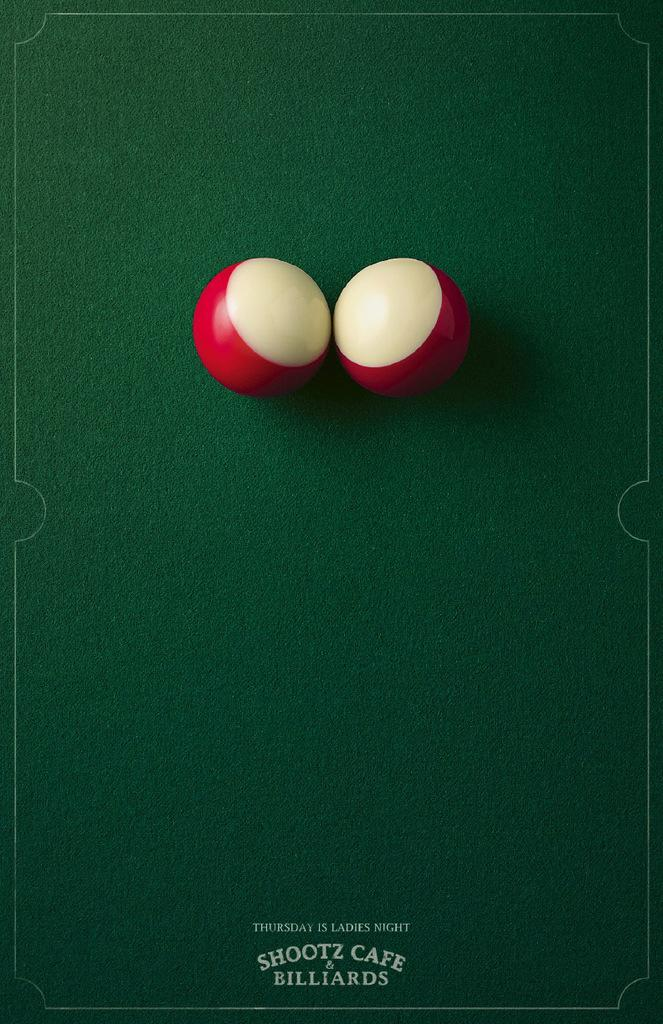What objects are on the green surface in the image? There are balls on a green surface in the image. What can be found at the bottom of the image? There is text at the bottom of the image. What type of coast can be seen in the image? There is no coast visible in the image; it features balls on a green surface and text at the bottom. 